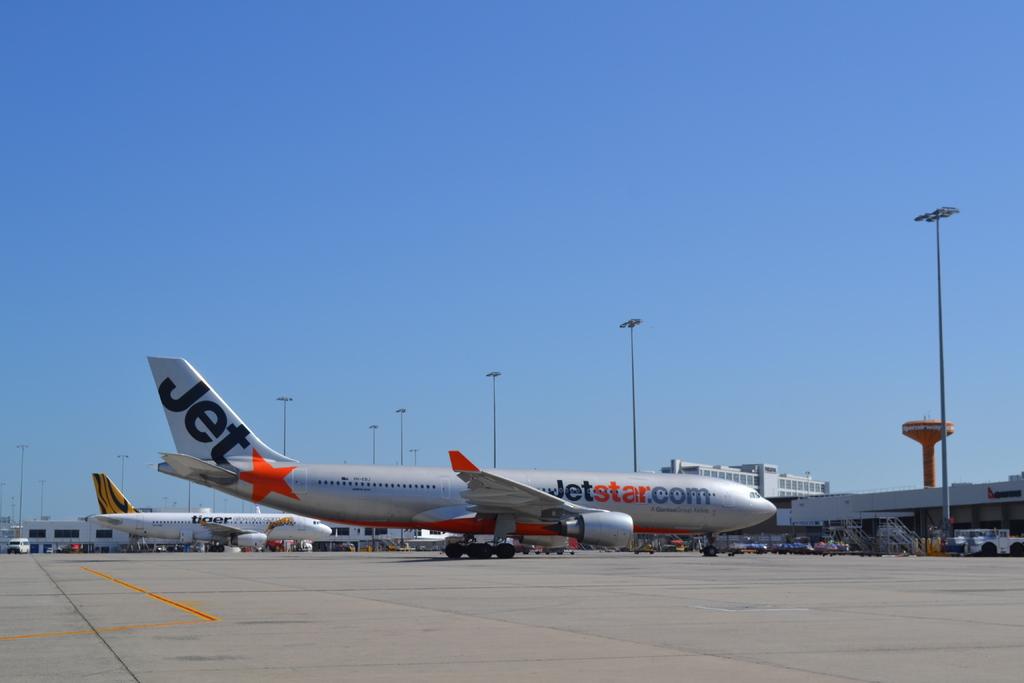What does it say near the star on the tail of the plane?
Make the answer very short. Jet. What website is written on the plane?
Your answer should be compact. Jetstar.com. 